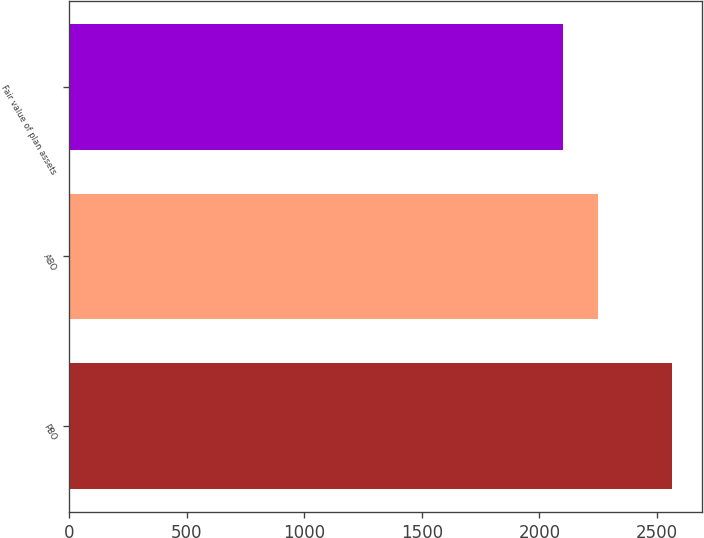Convert chart. <chart><loc_0><loc_0><loc_500><loc_500><bar_chart><fcel>PBO<fcel>ABO<fcel>Fair value of plan assets<nl><fcel>2562<fcel>2250<fcel>2101<nl></chart> 